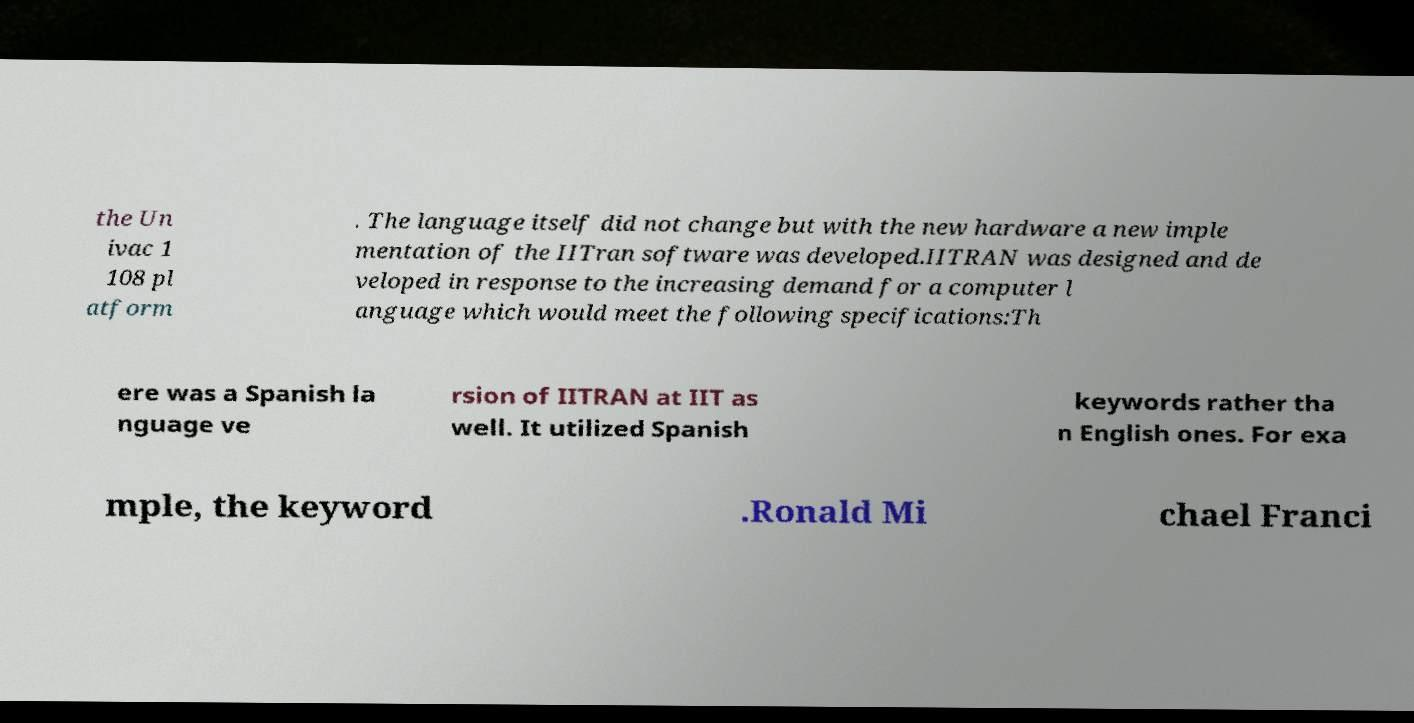Can you read and provide the text displayed in the image?This photo seems to have some interesting text. Can you extract and type it out for me? the Un ivac 1 108 pl atform . The language itself did not change but with the new hardware a new imple mentation of the IITran software was developed.IITRAN was designed and de veloped in response to the increasing demand for a computer l anguage which would meet the following specifications:Th ere was a Spanish la nguage ve rsion of IITRAN at IIT as well. It utilized Spanish keywords rather tha n English ones. For exa mple, the keyword .Ronald Mi chael Franci 